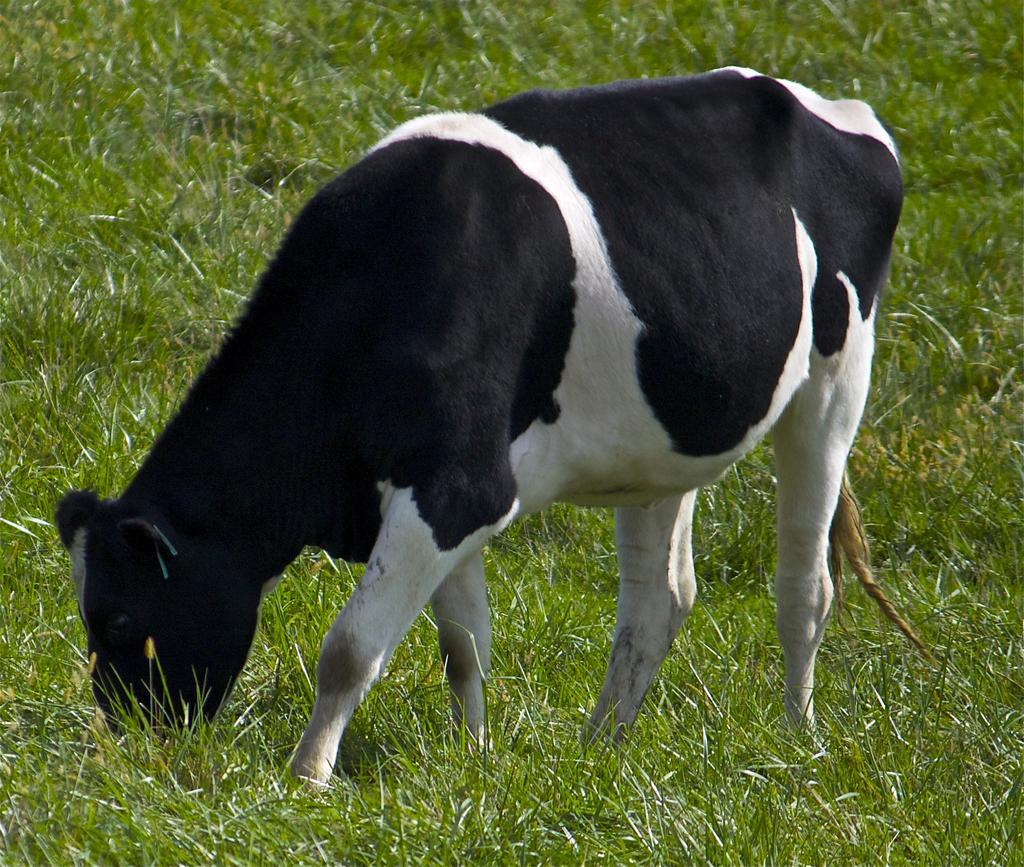Could you give a brief overview of what you see in this image? In this picture we can see an animal and in the background we can see the grass. 